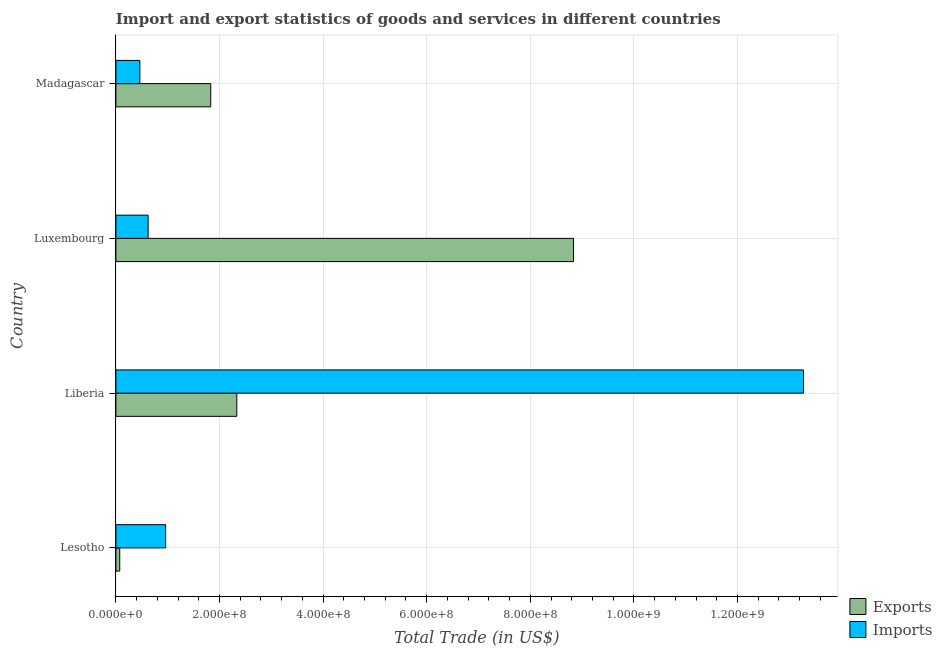How many different coloured bars are there?
Offer a terse response. 2. How many groups of bars are there?
Give a very brief answer. 4. Are the number of bars per tick equal to the number of legend labels?
Give a very brief answer. Yes. How many bars are there on the 2nd tick from the bottom?
Make the answer very short. 2. What is the label of the 1st group of bars from the top?
Provide a succinct answer. Madagascar. What is the export of goods and services in Liberia?
Keep it short and to the point. 2.33e+08. Across all countries, what is the maximum export of goods and services?
Offer a terse response. 8.83e+08. Across all countries, what is the minimum export of goods and services?
Keep it short and to the point. 7.42e+06. In which country was the export of goods and services maximum?
Provide a succinct answer. Luxembourg. In which country was the export of goods and services minimum?
Offer a very short reply. Lesotho. What is the total imports of goods and services in the graph?
Your answer should be compact. 1.53e+09. What is the difference between the export of goods and services in Lesotho and that in Luxembourg?
Keep it short and to the point. -8.76e+08. What is the difference between the export of goods and services in Luxembourg and the imports of goods and services in Madagascar?
Make the answer very short. 8.37e+08. What is the average imports of goods and services per country?
Your response must be concise. 3.83e+08. What is the difference between the imports of goods and services and export of goods and services in Lesotho?
Give a very brief answer. 8.86e+07. What is the ratio of the imports of goods and services in Luxembourg to that in Madagascar?
Give a very brief answer. 1.34. Is the export of goods and services in Lesotho less than that in Luxembourg?
Provide a short and direct response. Yes. Is the difference between the imports of goods and services in Luxembourg and Madagascar greater than the difference between the export of goods and services in Luxembourg and Madagascar?
Offer a very short reply. No. What is the difference between the highest and the second highest imports of goods and services?
Offer a terse response. 1.23e+09. What is the difference between the highest and the lowest export of goods and services?
Give a very brief answer. 8.76e+08. What does the 1st bar from the top in Madagascar represents?
Give a very brief answer. Imports. What does the 2nd bar from the bottom in Madagascar represents?
Keep it short and to the point. Imports. How many bars are there?
Your answer should be very brief. 8. Are all the bars in the graph horizontal?
Offer a terse response. Yes. How many countries are there in the graph?
Your response must be concise. 4. What is the difference between two consecutive major ticks on the X-axis?
Your answer should be very brief. 2.00e+08. Are the values on the major ticks of X-axis written in scientific E-notation?
Offer a very short reply. Yes. Does the graph contain any zero values?
Provide a short and direct response. No. Where does the legend appear in the graph?
Give a very brief answer. Bottom right. How many legend labels are there?
Your answer should be compact. 2. How are the legend labels stacked?
Provide a succinct answer. Vertical. What is the title of the graph?
Make the answer very short. Import and export statistics of goods and services in different countries. What is the label or title of the X-axis?
Provide a succinct answer. Total Trade (in US$). What is the label or title of the Y-axis?
Make the answer very short. Country. What is the Total Trade (in US$) in Exports in Lesotho?
Your answer should be compact. 7.42e+06. What is the Total Trade (in US$) of Imports in Lesotho?
Ensure brevity in your answer.  9.60e+07. What is the Total Trade (in US$) in Exports in Liberia?
Your answer should be very brief. 2.33e+08. What is the Total Trade (in US$) of Imports in Liberia?
Make the answer very short. 1.33e+09. What is the Total Trade (in US$) of Exports in Luxembourg?
Offer a terse response. 8.83e+08. What is the Total Trade (in US$) in Imports in Luxembourg?
Ensure brevity in your answer.  6.22e+07. What is the Total Trade (in US$) in Exports in Madagascar?
Your response must be concise. 1.83e+08. What is the Total Trade (in US$) of Imports in Madagascar?
Your answer should be compact. 4.62e+07. Across all countries, what is the maximum Total Trade (in US$) in Exports?
Give a very brief answer. 8.83e+08. Across all countries, what is the maximum Total Trade (in US$) of Imports?
Make the answer very short. 1.33e+09. Across all countries, what is the minimum Total Trade (in US$) in Exports?
Give a very brief answer. 7.42e+06. Across all countries, what is the minimum Total Trade (in US$) of Imports?
Your response must be concise. 4.62e+07. What is the total Total Trade (in US$) in Exports in the graph?
Make the answer very short. 1.31e+09. What is the total Total Trade (in US$) in Imports in the graph?
Offer a very short reply. 1.53e+09. What is the difference between the Total Trade (in US$) in Exports in Lesotho and that in Liberia?
Provide a short and direct response. -2.26e+08. What is the difference between the Total Trade (in US$) of Imports in Lesotho and that in Liberia?
Offer a very short reply. -1.23e+09. What is the difference between the Total Trade (in US$) in Exports in Lesotho and that in Luxembourg?
Give a very brief answer. -8.76e+08. What is the difference between the Total Trade (in US$) in Imports in Lesotho and that in Luxembourg?
Give a very brief answer. 3.38e+07. What is the difference between the Total Trade (in US$) of Exports in Lesotho and that in Madagascar?
Your response must be concise. -1.76e+08. What is the difference between the Total Trade (in US$) in Imports in Lesotho and that in Madagascar?
Give a very brief answer. 4.98e+07. What is the difference between the Total Trade (in US$) of Exports in Liberia and that in Luxembourg?
Offer a very short reply. -6.50e+08. What is the difference between the Total Trade (in US$) in Imports in Liberia and that in Luxembourg?
Provide a short and direct response. 1.27e+09. What is the difference between the Total Trade (in US$) in Exports in Liberia and that in Madagascar?
Make the answer very short. 5.03e+07. What is the difference between the Total Trade (in US$) in Imports in Liberia and that in Madagascar?
Your answer should be compact. 1.28e+09. What is the difference between the Total Trade (in US$) in Exports in Luxembourg and that in Madagascar?
Provide a succinct answer. 7.00e+08. What is the difference between the Total Trade (in US$) in Imports in Luxembourg and that in Madagascar?
Keep it short and to the point. 1.60e+07. What is the difference between the Total Trade (in US$) in Exports in Lesotho and the Total Trade (in US$) in Imports in Liberia?
Offer a very short reply. -1.32e+09. What is the difference between the Total Trade (in US$) in Exports in Lesotho and the Total Trade (in US$) in Imports in Luxembourg?
Ensure brevity in your answer.  -5.48e+07. What is the difference between the Total Trade (in US$) in Exports in Lesotho and the Total Trade (in US$) in Imports in Madagascar?
Your response must be concise. -3.88e+07. What is the difference between the Total Trade (in US$) of Exports in Liberia and the Total Trade (in US$) of Imports in Luxembourg?
Provide a succinct answer. 1.71e+08. What is the difference between the Total Trade (in US$) of Exports in Liberia and the Total Trade (in US$) of Imports in Madagascar?
Provide a short and direct response. 1.87e+08. What is the difference between the Total Trade (in US$) of Exports in Luxembourg and the Total Trade (in US$) of Imports in Madagascar?
Offer a very short reply. 8.37e+08. What is the average Total Trade (in US$) in Exports per country?
Offer a very short reply. 3.27e+08. What is the average Total Trade (in US$) in Imports per country?
Your response must be concise. 3.83e+08. What is the difference between the Total Trade (in US$) in Exports and Total Trade (in US$) in Imports in Lesotho?
Offer a very short reply. -8.86e+07. What is the difference between the Total Trade (in US$) of Exports and Total Trade (in US$) of Imports in Liberia?
Provide a succinct answer. -1.09e+09. What is the difference between the Total Trade (in US$) of Exports and Total Trade (in US$) of Imports in Luxembourg?
Your answer should be compact. 8.21e+08. What is the difference between the Total Trade (in US$) in Exports and Total Trade (in US$) in Imports in Madagascar?
Your answer should be very brief. 1.37e+08. What is the ratio of the Total Trade (in US$) in Exports in Lesotho to that in Liberia?
Your answer should be compact. 0.03. What is the ratio of the Total Trade (in US$) of Imports in Lesotho to that in Liberia?
Give a very brief answer. 0.07. What is the ratio of the Total Trade (in US$) in Exports in Lesotho to that in Luxembourg?
Ensure brevity in your answer.  0.01. What is the ratio of the Total Trade (in US$) of Imports in Lesotho to that in Luxembourg?
Provide a short and direct response. 1.54. What is the ratio of the Total Trade (in US$) in Exports in Lesotho to that in Madagascar?
Your response must be concise. 0.04. What is the ratio of the Total Trade (in US$) in Imports in Lesotho to that in Madagascar?
Offer a terse response. 2.08. What is the ratio of the Total Trade (in US$) in Exports in Liberia to that in Luxembourg?
Make the answer very short. 0.26. What is the ratio of the Total Trade (in US$) in Imports in Liberia to that in Luxembourg?
Offer a very short reply. 21.34. What is the ratio of the Total Trade (in US$) of Exports in Liberia to that in Madagascar?
Ensure brevity in your answer.  1.27. What is the ratio of the Total Trade (in US$) in Imports in Liberia to that in Madagascar?
Offer a very short reply. 28.71. What is the ratio of the Total Trade (in US$) of Exports in Luxembourg to that in Madagascar?
Your answer should be very brief. 4.82. What is the ratio of the Total Trade (in US$) of Imports in Luxembourg to that in Madagascar?
Give a very brief answer. 1.35. What is the difference between the highest and the second highest Total Trade (in US$) in Exports?
Provide a succinct answer. 6.50e+08. What is the difference between the highest and the second highest Total Trade (in US$) in Imports?
Give a very brief answer. 1.23e+09. What is the difference between the highest and the lowest Total Trade (in US$) in Exports?
Keep it short and to the point. 8.76e+08. What is the difference between the highest and the lowest Total Trade (in US$) of Imports?
Keep it short and to the point. 1.28e+09. 